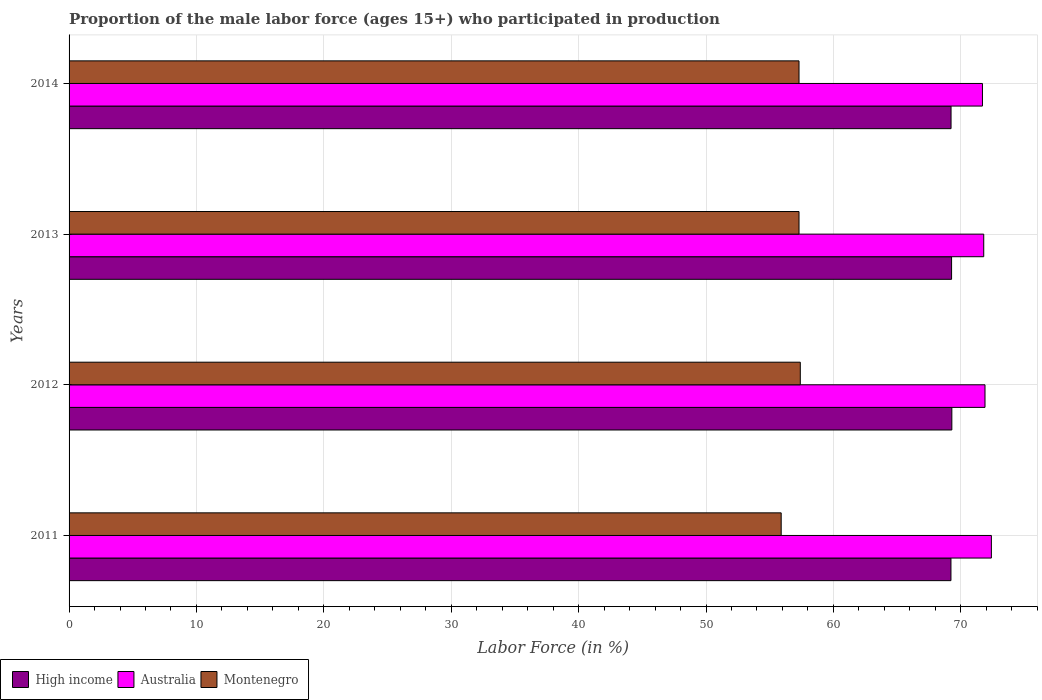Are the number of bars per tick equal to the number of legend labels?
Make the answer very short. Yes. How many bars are there on the 2nd tick from the bottom?
Give a very brief answer. 3. What is the label of the 1st group of bars from the top?
Make the answer very short. 2014. In how many cases, is the number of bars for a given year not equal to the number of legend labels?
Your answer should be very brief. 0. What is the proportion of the male labor force who participated in production in Australia in 2014?
Make the answer very short. 71.7. Across all years, what is the maximum proportion of the male labor force who participated in production in Australia?
Keep it short and to the point. 72.4. Across all years, what is the minimum proportion of the male labor force who participated in production in Australia?
Make the answer very short. 71.7. In which year was the proportion of the male labor force who participated in production in Australia maximum?
Provide a succinct answer. 2011. What is the total proportion of the male labor force who participated in production in Australia in the graph?
Offer a terse response. 287.8. What is the difference between the proportion of the male labor force who participated in production in Montenegro in 2012 and that in 2013?
Your answer should be very brief. 0.1. What is the difference between the proportion of the male labor force who participated in production in Montenegro in 2011 and the proportion of the male labor force who participated in production in Australia in 2013?
Offer a terse response. -15.9. What is the average proportion of the male labor force who participated in production in Montenegro per year?
Provide a succinct answer. 56.98. In the year 2014, what is the difference between the proportion of the male labor force who participated in production in Australia and proportion of the male labor force who participated in production in High income?
Give a very brief answer. 2.47. What is the ratio of the proportion of the male labor force who participated in production in High income in 2012 to that in 2013?
Offer a very short reply. 1. Is the difference between the proportion of the male labor force who participated in production in Australia in 2012 and 2013 greater than the difference between the proportion of the male labor force who participated in production in High income in 2012 and 2013?
Ensure brevity in your answer.  Yes. What is the difference between the highest and the second highest proportion of the male labor force who participated in production in Australia?
Offer a very short reply. 0.5. What is the difference between the highest and the lowest proportion of the male labor force who participated in production in High income?
Ensure brevity in your answer.  0.07. What does the 2nd bar from the bottom in 2012 represents?
Ensure brevity in your answer.  Australia. Is it the case that in every year, the sum of the proportion of the male labor force who participated in production in High income and proportion of the male labor force who participated in production in Australia is greater than the proportion of the male labor force who participated in production in Montenegro?
Provide a succinct answer. Yes. How many years are there in the graph?
Offer a terse response. 4. What is the difference between two consecutive major ticks on the X-axis?
Offer a terse response. 10. Does the graph contain any zero values?
Offer a very short reply. No. How many legend labels are there?
Keep it short and to the point. 3. What is the title of the graph?
Your response must be concise. Proportion of the male labor force (ages 15+) who participated in production. Does "Iraq" appear as one of the legend labels in the graph?
Make the answer very short. No. What is the label or title of the X-axis?
Provide a short and direct response. Labor Force (in %). What is the label or title of the Y-axis?
Provide a short and direct response. Years. What is the Labor Force (in %) of High income in 2011?
Your answer should be compact. 69.23. What is the Labor Force (in %) in Australia in 2011?
Your answer should be very brief. 72.4. What is the Labor Force (in %) in Montenegro in 2011?
Provide a succinct answer. 55.9. What is the Labor Force (in %) of High income in 2012?
Provide a short and direct response. 69.3. What is the Labor Force (in %) in Australia in 2012?
Ensure brevity in your answer.  71.9. What is the Labor Force (in %) in Montenegro in 2012?
Offer a terse response. 57.4. What is the Labor Force (in %) in High income in 2013?
Make the answer very short. 69.28. What is the Labor Force (in %) of Australia in 2013?
Give a very brief answer. 71.8. What is the Labor Force (in %) in Montenegro in 2013?
Your answer should be very brief. 57.3. What is the Labor Force (in %) in High income in 2014?
Ensure brevity in your answer.  69.23. What is the Labor Force (in %) in Australia in 2014?
Offer a very short reply. 71.7. What is the Labor Force (in %) in Montenegro in 2014?
Offer a terse response. 57.3. Across all years, what is the maximum Labor Force (in %) in High income?
Make the answer very short. 69.3. Across all years, what is the maximum Labor Force (in %) of Australia?
Provide a short and direct response. 72.4. Across all years, what is the maximum Labor Force (in %) of Montenegro?
Your response must be concise. 57.4. Across all years, what is the minimum Labor Force (in %) in High income?
Offer a very short reply. 69.23. Across all years, what is the minimum Labor Force (in %) of Australia?
Provide a short and direct response. 71.7. Across all years, what is the minimum Labor Force (in %) in Montenegro?
Make the answer very short. 55.9. What is the total Labor Force (in %) of High income in the graph?
Your answer should be compact. 277.03. What is the total Labor Force (in %) of Australia in the graph?
Give a very brief answer. 287.8. What is the total Labor Force (in %) of Montenegro in the graph?
Keep it short and to the point. 227.9. What is the difference between the Labor Force (in %) in High income in 2011 and that in 2012?
Your answer should be compact. -0.07. What is the difference between the Labor Force (in %) in Australia in 2011 and that in 2012?
Provide a short and direct response. 0.5. What is the difference between the Labor Force (in %) of Montenegro in 2011 and that in 2012?
Ensure brevity in your answer.  -1.5. What is the difference between the Labor Force (in %) in High income in 2011 and that in 2013?
Your answer should be very brief. -0.05. What is the difference between the Labor Force (in %) of High income in 2011 and that in 2014?
Your answer should be compact. -0.01. What is the difference between the Labor Force (in %) of Australia in 2011 and that in 2014?
Make the answer very short. 0.7. What is the difference between the Labor Force (in %) in Montenegro in 2011 and that in 2014?
Provide a succinct answer. -1.4. What is the difference between the Labor Force (in %) in High income in 2012 and that in 2013?
Offer a very short reply. 0.02. What is the difference between the Labor Force (in %) in Montenegro in 2012 and that in 2013?
Provide a succinct answer. 0.1. What is the difference between the Labor Force (in %) in High income in 2012 and that in 2014?
Your answer should be compact. 0.06. What is the difference between the Labor Force (in %) in Australia in 2012 and that in 2014?
Keep it short and to the point. 0.2. What is the difference between the Labor Force (in %) of Montenegro in 2012 and that in 2014?
Provide a succinct answer. 0.1. What is the difference between the Labor Force (in %) in High income in 2013 and that in 2014?
Offer a terse response. 0.04. What is the difference between the Labor Force (in %) of High income in 2011 and the Labor Force (in %) of Australia in 2012?
Make the answer very short. -2.67. What is the difference between the Labor Force (in %) of High income in 2011 and the Labor Force (in %) of Montenegro in 2012?
Provide a short and direct response. 11.83. What is the difference between the Labor Force (in %) in Australia in 2011 and the Labor Force (in %) in Montenegro in 2012?
Keep it short and to the point. 15. What is the difference between the Labor Force (in %) in High income in 2011 and the Labor Force (in %) in Australia in 2013?
Keep it short and to the point. -2.57. What is the difference between the Labor Force (in %) of High income in 2011 and the Labor Force (in %) of Montenegro in 2013?
Make the answer very short. 11.93. What is the difference between the Labor Force (in %) in High income in 2011 and the Labor Force (in %) in Australia in 2014?
Your answer should be very brief. -2.47. What is the difference between the Labor Force (in %) in High income in 2011 and the Labor Force (in %) in Montenegro in 2014?
Keep it short and to the point. 11.93. What is the difference between the Labor Force (in %) in Australia in 2011 and the Labor Force (in %) in Montenegro in 2014?
Make the answer very short. 15.1. What is the difference between the Labor Force (in %) in High income in 2012 and the Labor Force (in %) in Australia in 2013?
Offer a terse response. -2.5. What is the difference between the Labor Force (in %) of High income in 2012 and the Labor Force (in %) of Montenegro in 2013?
Offer a terse response. 12. What is the difference between the Labor Force (in %) of High income in 2012 and the Labor Force (in %) of Australia in 2014?
Ensure brevity in your answer.  -2.4. What is the difference between the Labor Force (in %) in High income in 2012 and the Labor Force (in %) in Montenegro in 2014?
Your answer should be compact. 12. What is the difference between the Labor Force (in %) of High income in 2013 and the Labor Force (in %) of Australia in 2014?
Provide a succinct answer. -2.42. What is the difference between the Labor Force (in %) in High income in 2013 and the Labor Force (in %) in Montenegro in 2014?
Your answer should be compact. 11.98. What is the average Labor Force (in %) of High income per year?
Your response must be concise. 69.26. What is the average Labor Force (in %) in Australia per year?
Offer a very short reply. 71.95. What is the average Labor Force (in %) in Montenegro per year?
Provide a succinct answer. 56.98. In the year 2011, what is the difference between the Labor Force (in %) in High income and Labor Force (in %) in Australia?
Offer a very short reply. -3.17. In the year 2011, what is the difference between the Labor Force (in %) of High income and Labor Force (in %) of Montenegro?
Keep it short and to the point. 13.33. In the year 2012, what is the difference between the Labor Force (in %) of High income and Labor Force (in %) of Australia?
Your answer should be very brief. -2.6. In the year 2012, what is the difference between the Labor Force (in %) in High income and Labor Force (in %) in Montenegro?
Your answer should be very brief. 11.9. In the year 2012, what is the difference between the Labor Force (in %) of Australia and Labor Force (in %) of Montenegro?
Provide a short and direct response. 14.5. In the year 2013, what is the difference between the Labor Force (in %) in High income and Labor Force (in %) in Australia?
Offer a very short reply. -2.52. In the year 2013, what is the difference between the Labor Force (in %) in High income and Labor Force (in %) in Montenegro?
Keep it short and to the point. 11.98. In the year 2014, what is the difference between the Labor Force (in %) of High income and Labor Force (in %) of Australia?
Offer a very short reply. -2.47. In the year 2014, what is the difference between the Labor Force (in %) in High income and Labor Force (in %) in Montenegro?
Keep it short and to the point. 11.93. In the year 2014, what is the difference between the Labor Force (in %) in Australia and Labor Force (in %) in Montenegro?
Make the answer very short. 14.4. What is the ratio of the Labor Force (in %) in High income in 2011 to that in 2012?
Offer a very short reply. 1. What is the ratio of the Labor Force (in %) in Montenegro in 2011 to that in 2012?
Provide a short and direct response. 0.97. What is the ratio of the Labor Force (in %) of High income in 2011 to that in 2013?
Keep it short and to the point. 1. What is the ratio of the Labor Force (in %) of Australia in 2011 to that in 2013?
Your answer should be very brief. 1.01. What is the ratio of the Labor Force (in %) in Montenegro in 2011 to that in 2013?
Offer a very short reply. 0.98. What is the ratio of the Labor Force (in %) in Australia in 2011 to that in 2014?
Your answer should be very brief. 1.01. What is the ratio of the Labor Force (in %) of Montenegro in 2011 to that in 2014?
Keep it short and to the point. 0.98. What is the ratio of the Labor Force (in %) of Australia in 2012 to that in 2013?
Make the answer very short. 1. What is the ratio of the Labor Force (in %) of Australia in 2012 to that in 2014?
Give a very brief answer. 1. What is the ratio of the Labor Force (in %) of Montenegro in 2012 to that in 2014?
Make the answer very short. 1. What is the ratio of the Labor Force (in %) in Australia in 2013 to that in 2014?
Your response must be concise. 1. What is the ratio of the Labor Force (in %) of Montenegro in 2013 to that in 2014?
Provide a succinct answer. 1. What is the difference between the highest and the second highest Labor Force (in %) in High income?
Offer a very short reply. 0.02. What is the difference between the highest and the second highest Labor Force (in %) of Australia?
Your response must be concise. 0.5. What is the difference between the highest and the lowest Labor Force (in %) in High income?
Offer a very short reply. 0.07. What is the difference between the highest and the lowest Labor Force (in %) of Australia?
Keep it short and to the point. 0.7. 